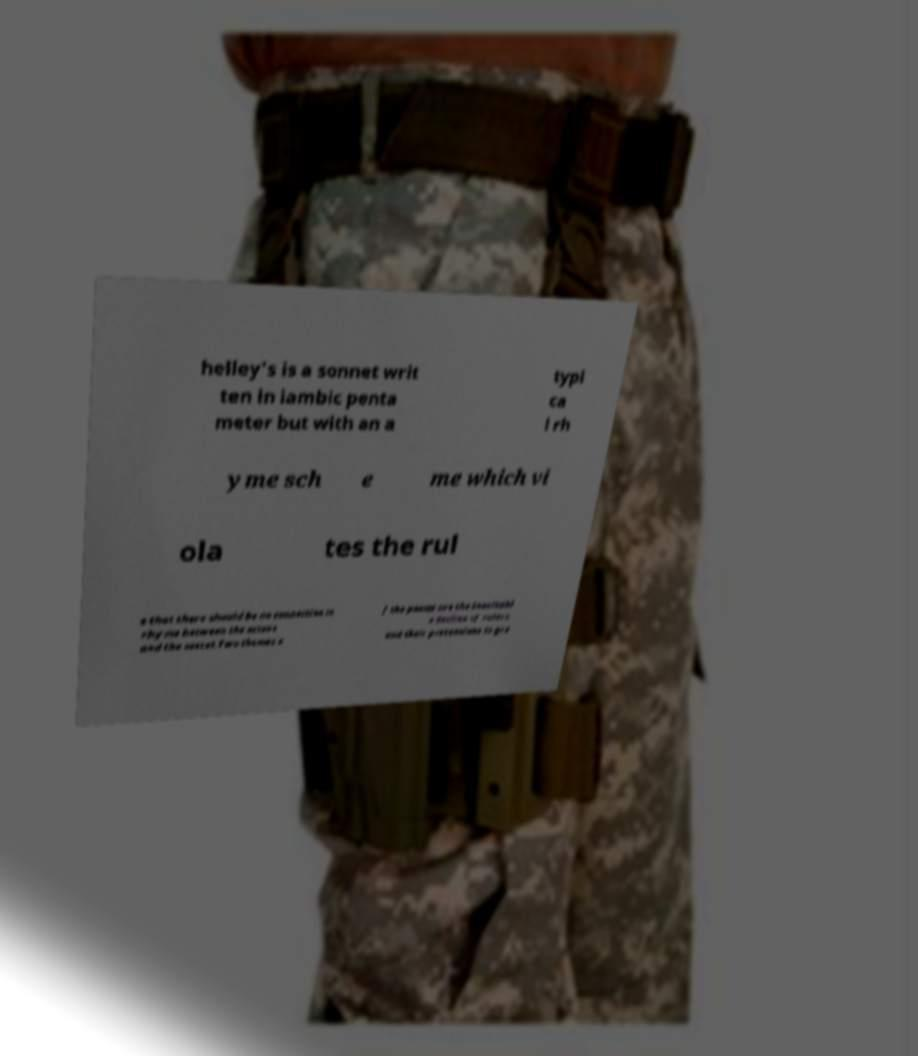For documentation purposes, I need the text within this image transcribed. Could you provide that? helley's is a sonnet writ ten in iambic penta meter but with an a typi ca l rh yme sch e me which vi ola tes the rul e that there should be no connection in rhyme between the octave and the sestet.Two themes o f the poems are the inevitabl e decline of rulers and their pretensions to gre 